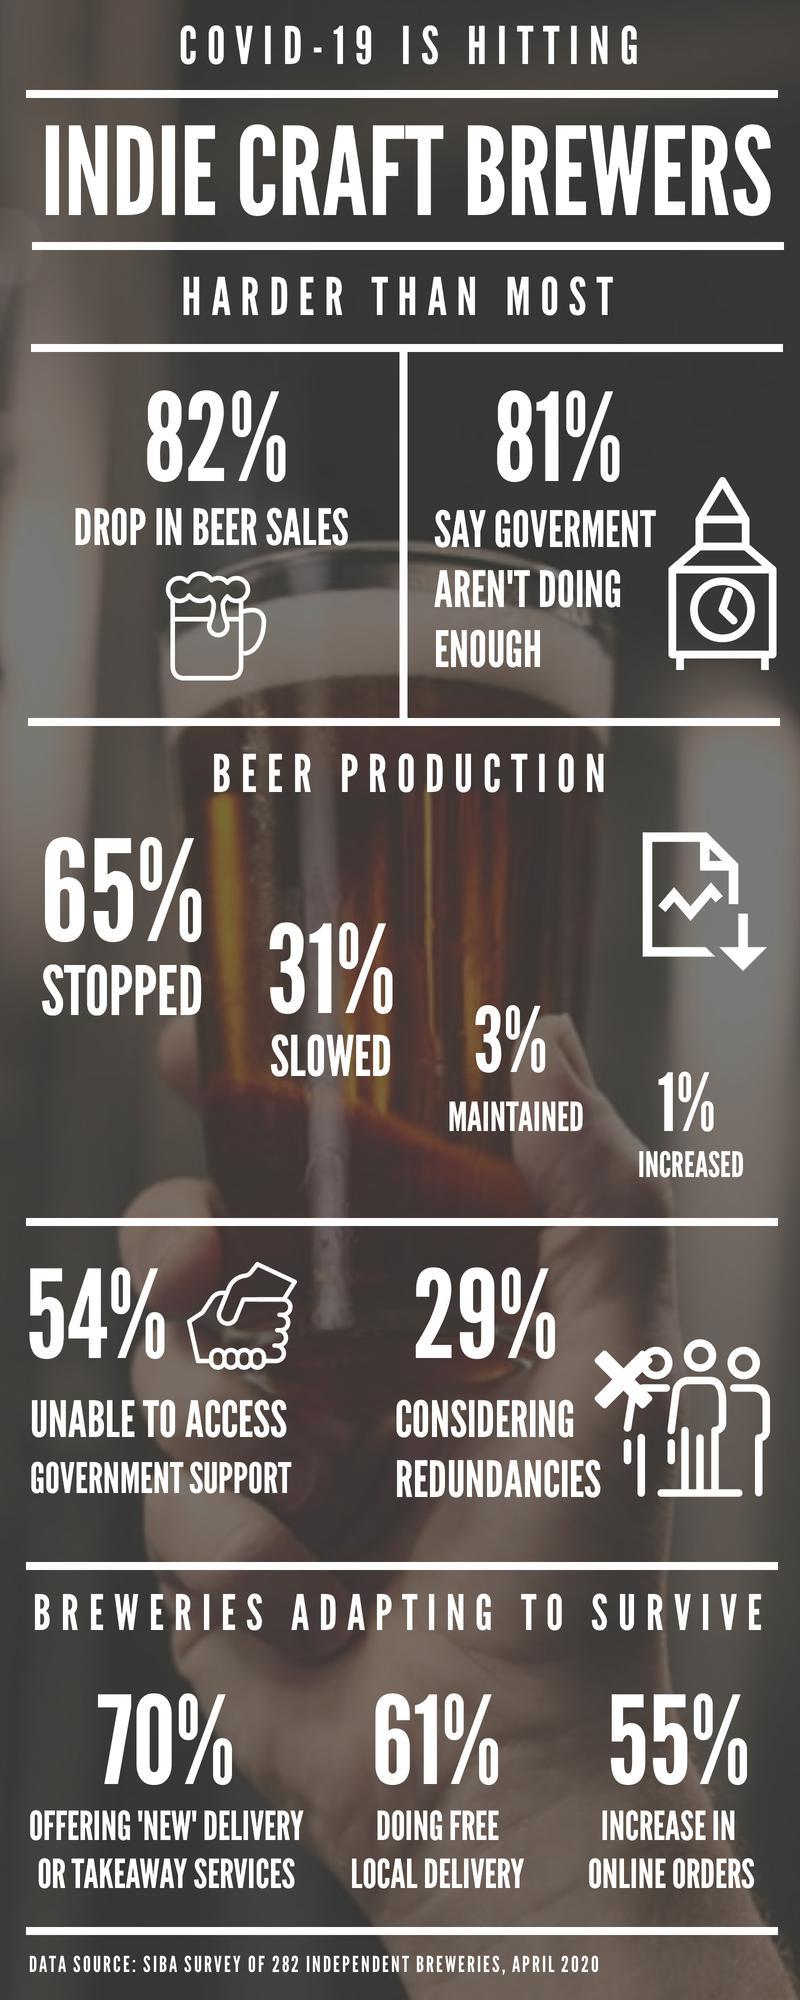What percentage of people are saying that the government is doing enough?
Answer the question with a short phrase. 19% What percentage of people able to access government support? 46% What is the percentage of paid local delivery? 39% 